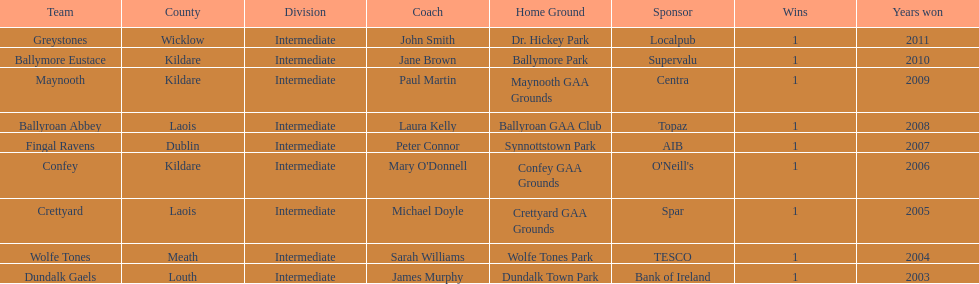Which is the first team from the chart Greystones. 